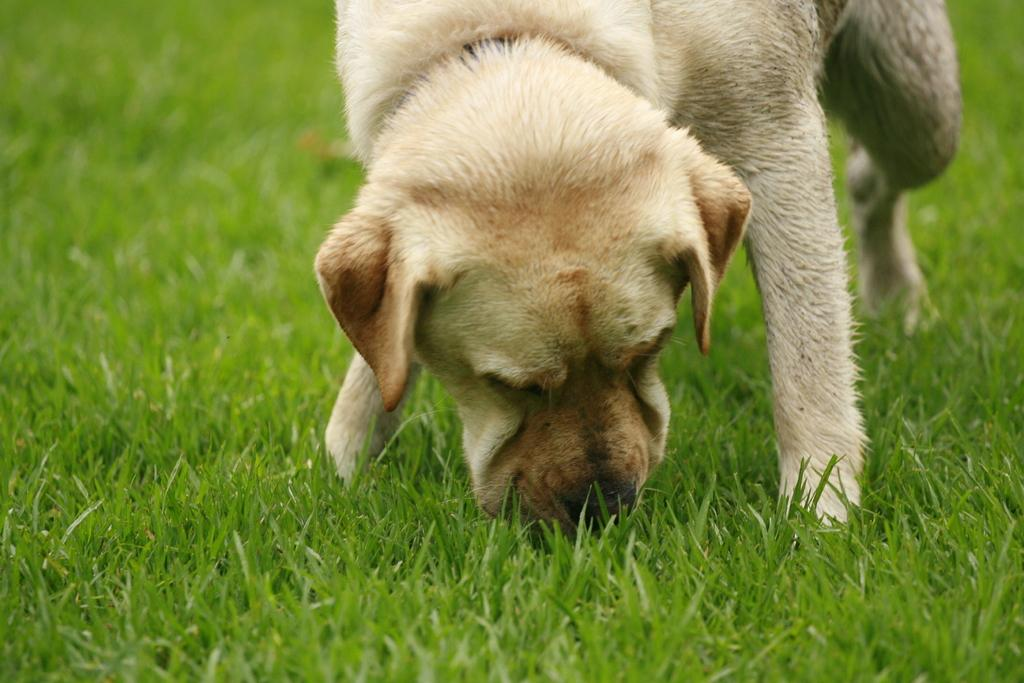What animal can be seen in the image? There is a dog in the image. What is the dog doing in the image? The dog is grazing the grass. Where is the dog standing in the image? The dog is standing on the ground. What type of vegetation is present on the ground? The ground is filled with grass. What type of doctor is attending the party in the image? There is no doctor or party present in the image; it features a dog grazing the grass on the ground. 